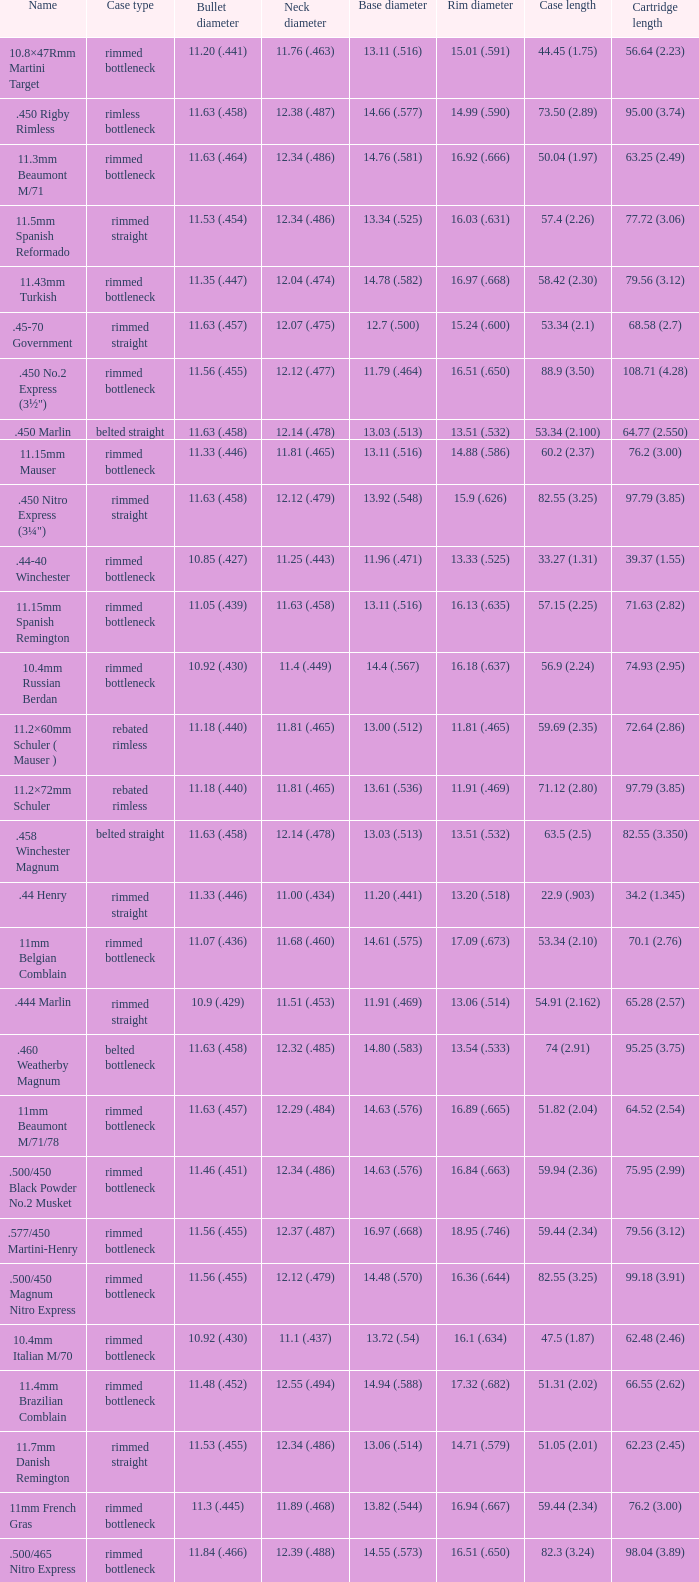Which Rim diameter has a Neck diameter of 11.84 (.466)? 15.67 (.617). 